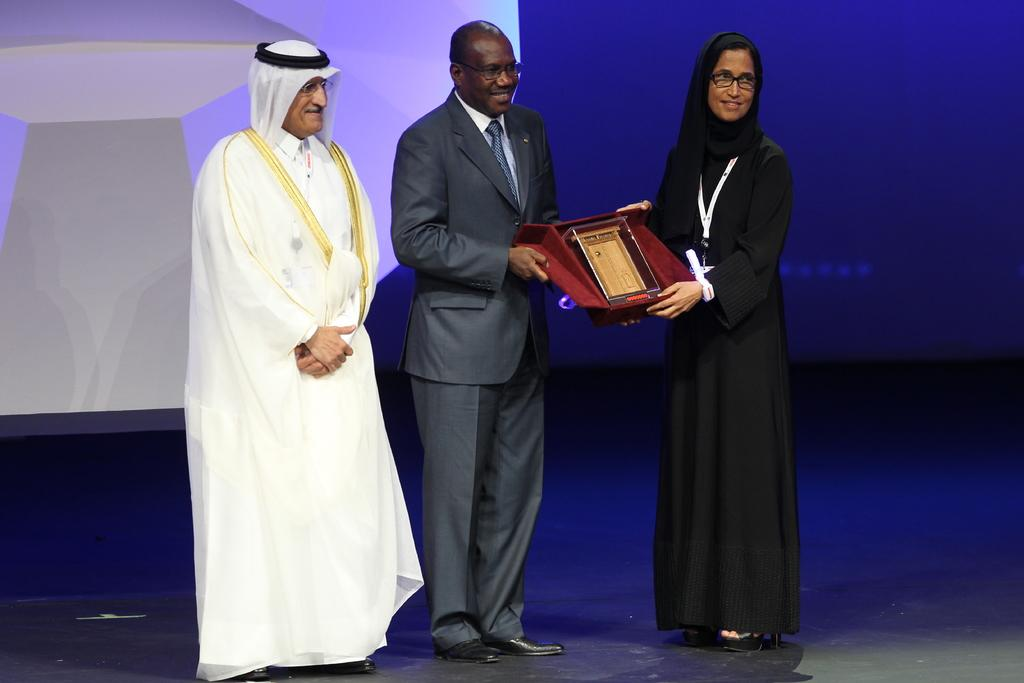How many people are on the stage in the image? There are three people standing on the stage. What are two of the people doing? Two people are holding a box. What can be found inside the box? There is an object inside the box. What is located behind the people on the stage? There is a screen behind the people. What type of scissors are being used to cut the chain on the businessman's neck in the image? There is no chain or businessman present in the image. What type of business is being conducted on the stage in the image? The image does not depict any business activities; it only shows three people standing on the stage and holding a box. 